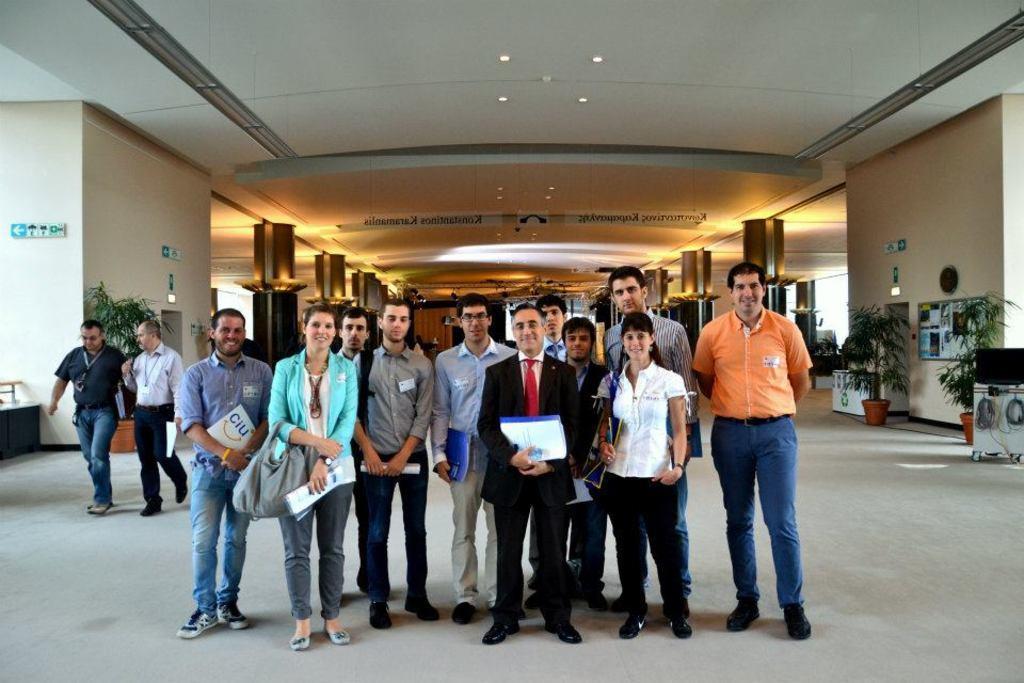Please provide a concise description of this image. In this image there are people standing, holding file in their hands on a floor, in the background there are people walking and there are walls, plants, at the top there is a ceiling for that ceiling there are lights. 